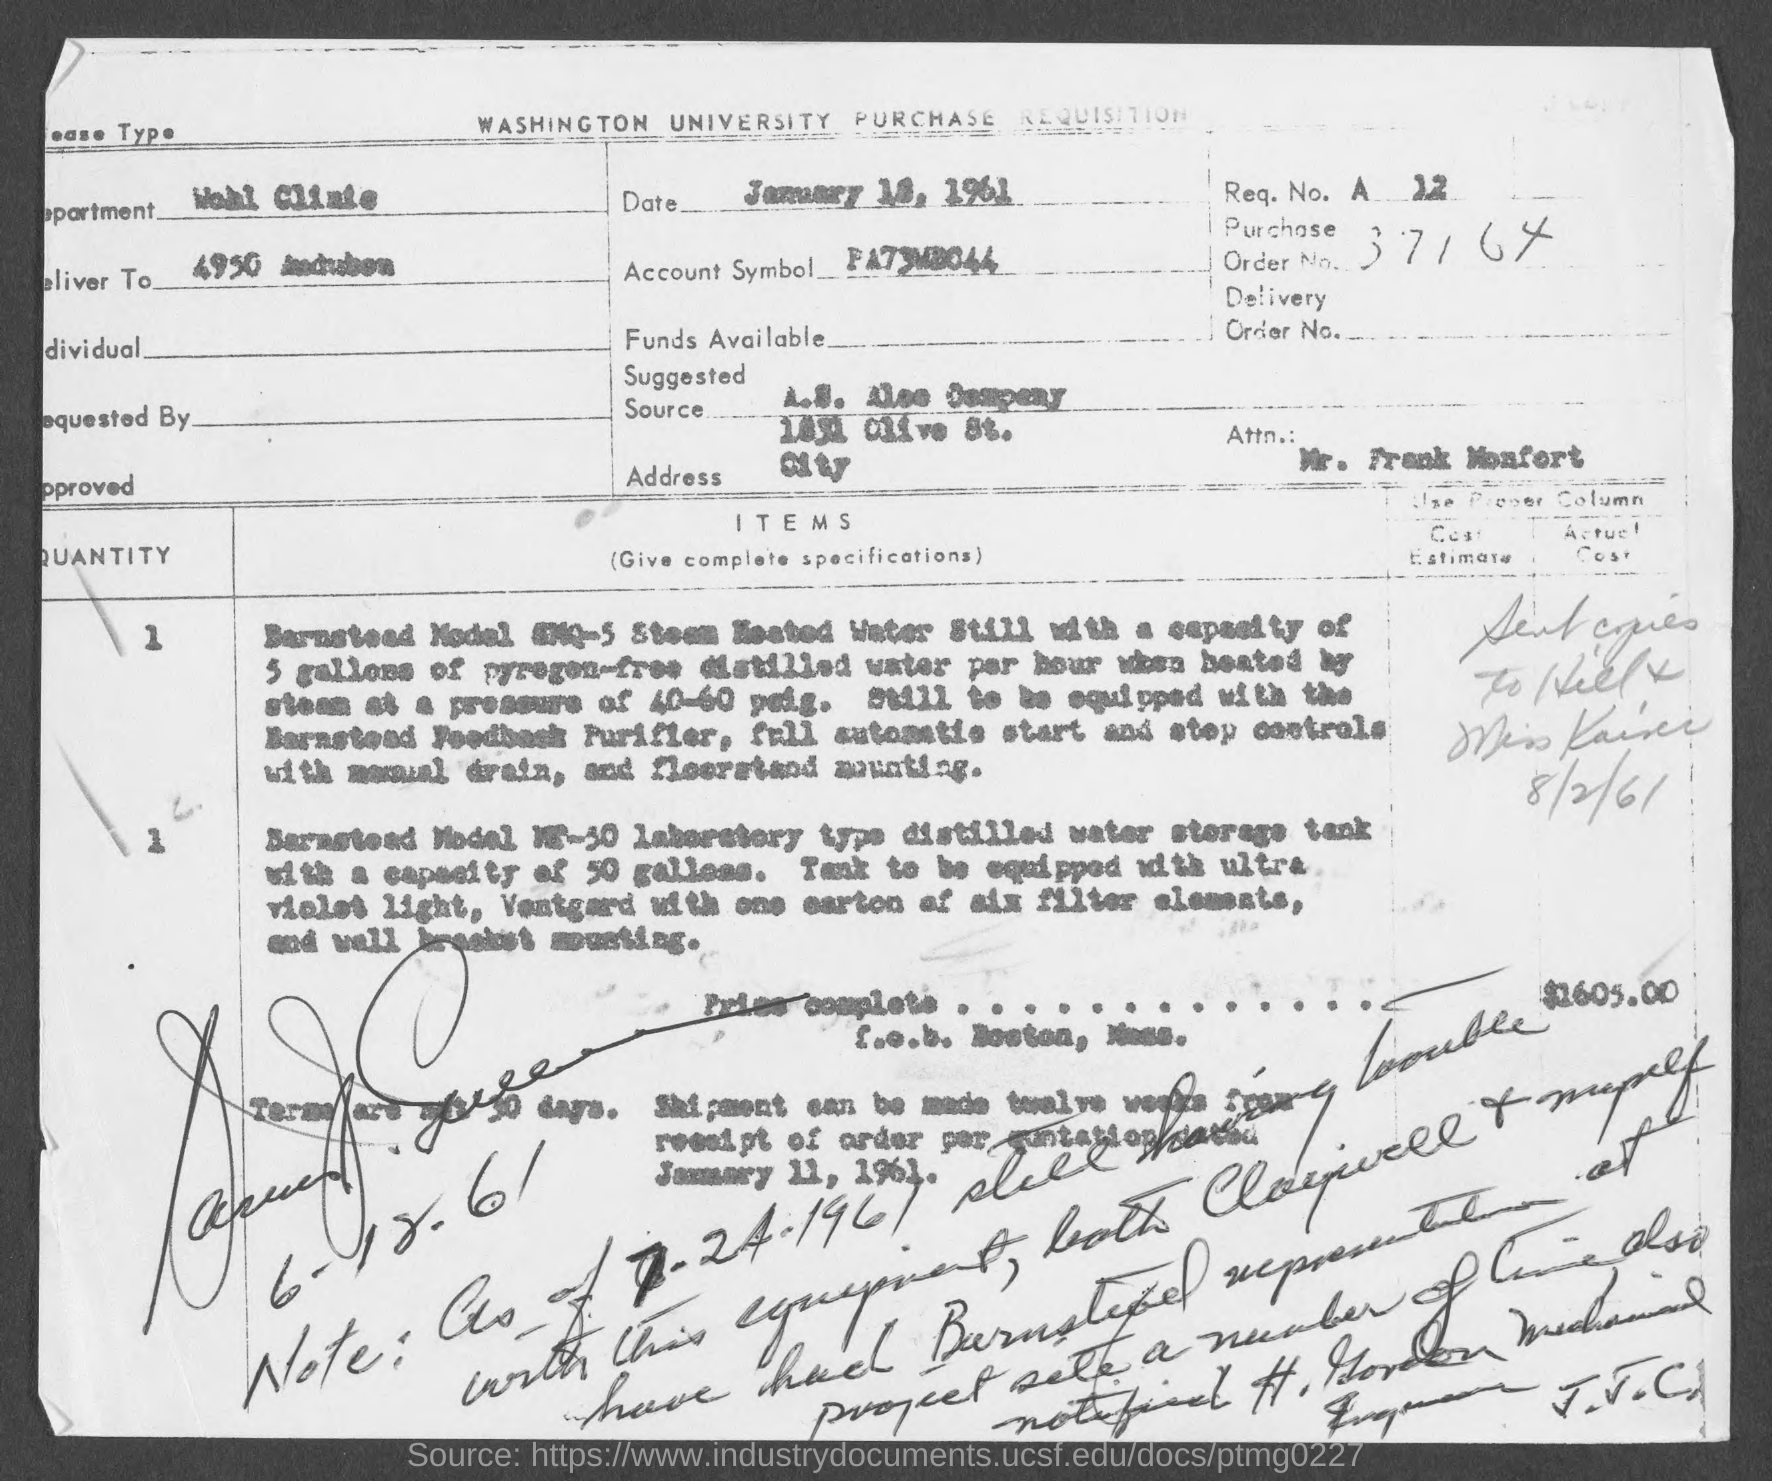Highlight a few significant elements in this photo. The recipient of this letter is Mr. Frank Monfort. The Wohl Clinic is the department. 